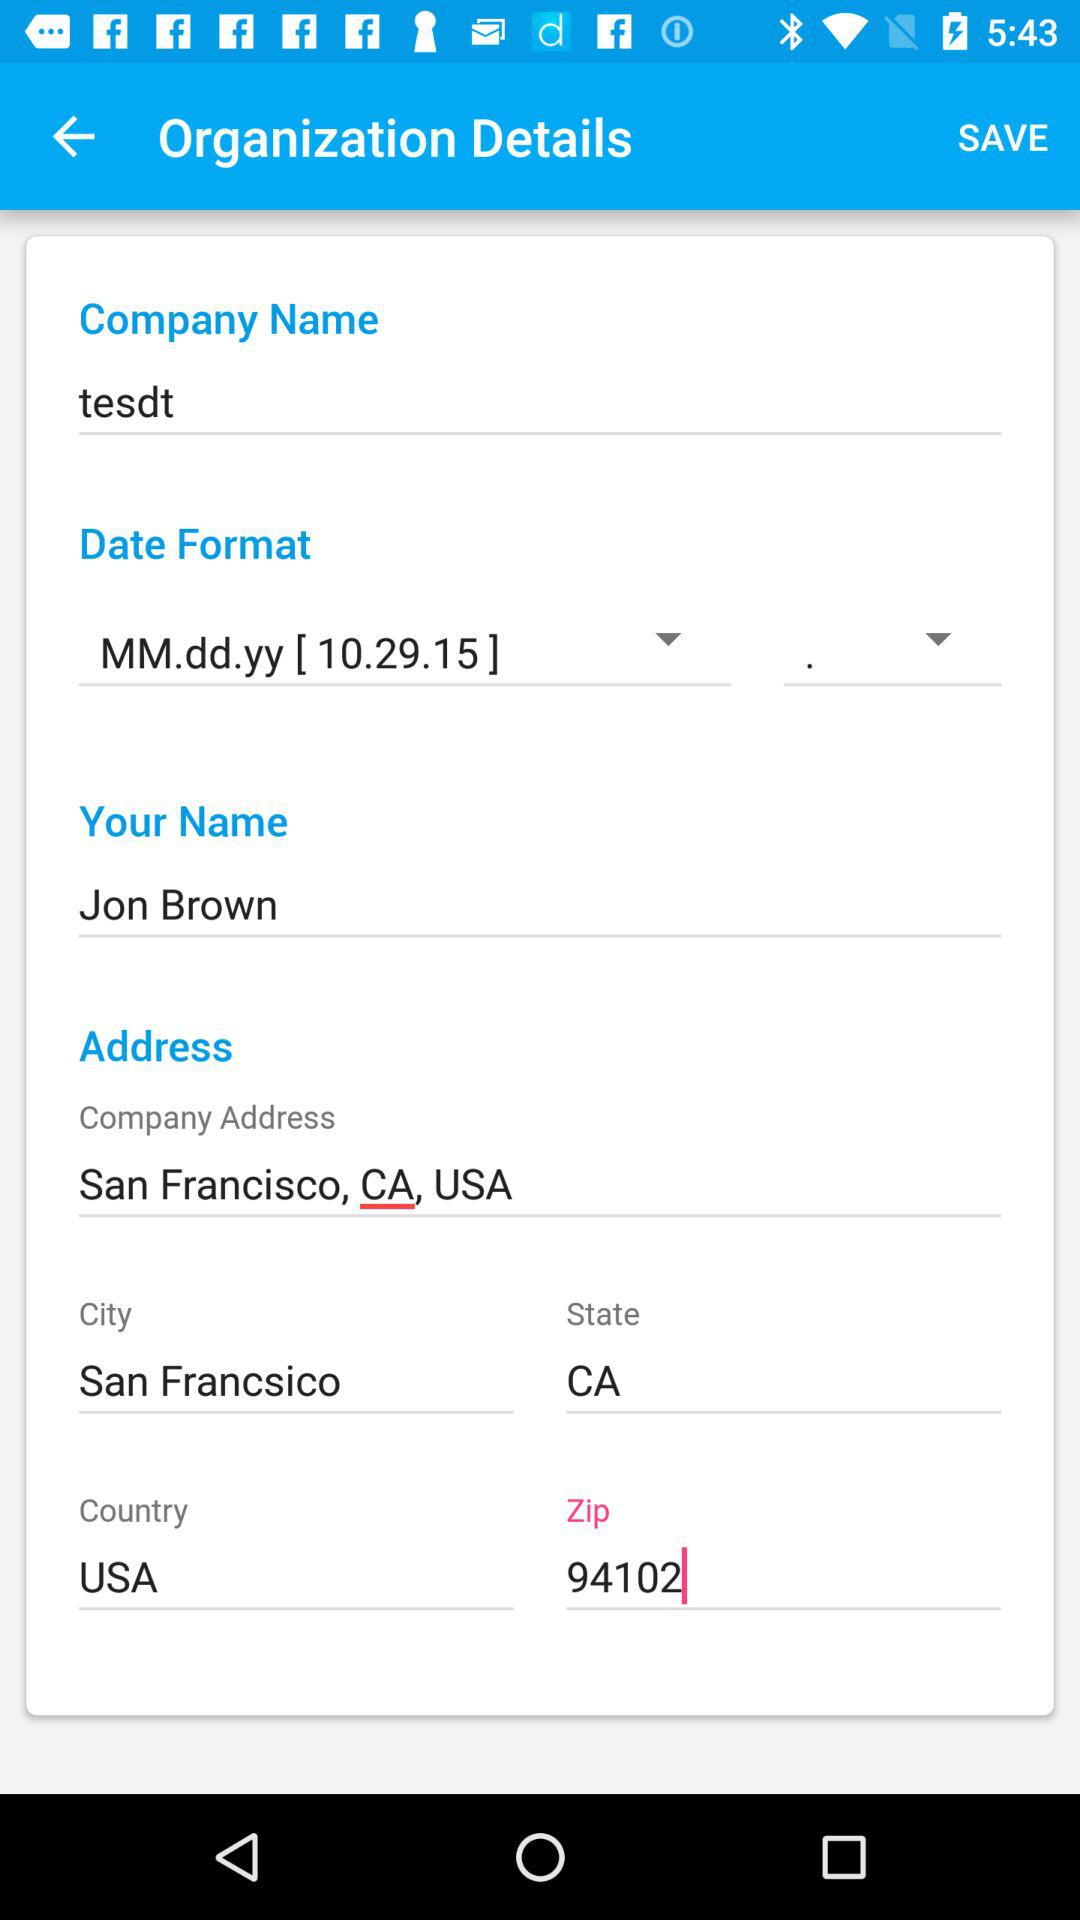What is the user name given? The user name given is Jon Brown. 